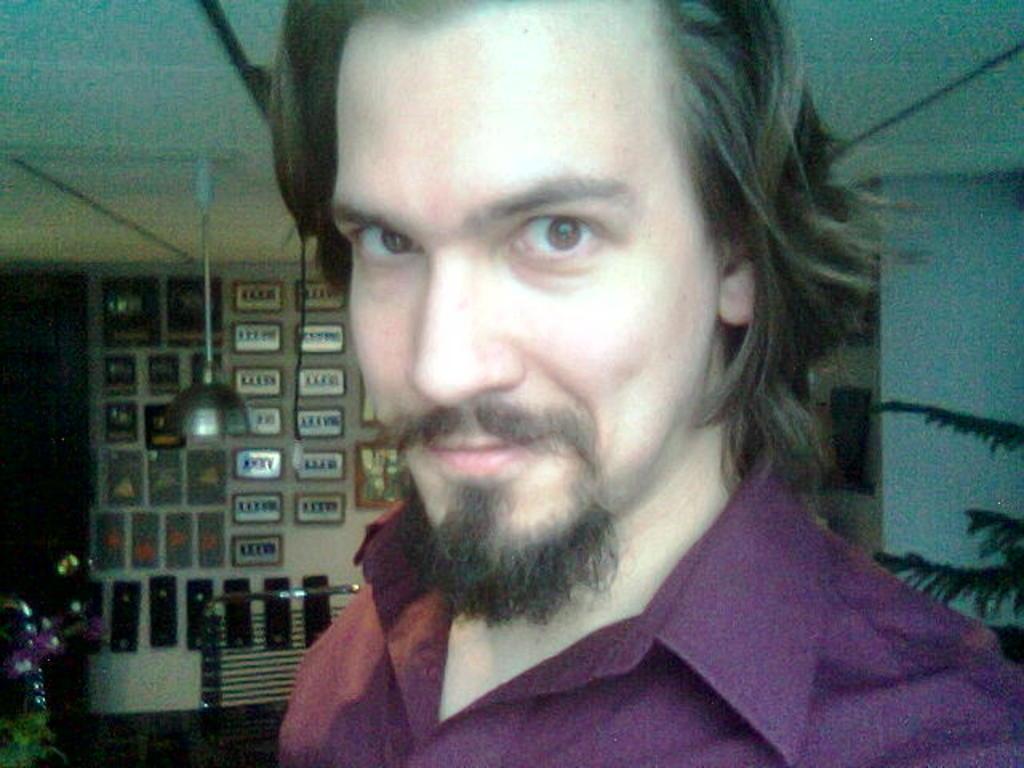Describe this image in one or two sentences. In this image I can see a man is smiling, he wore shirt. On the right side there are leaves of the plant, on the left side there are boards tot this wall. 